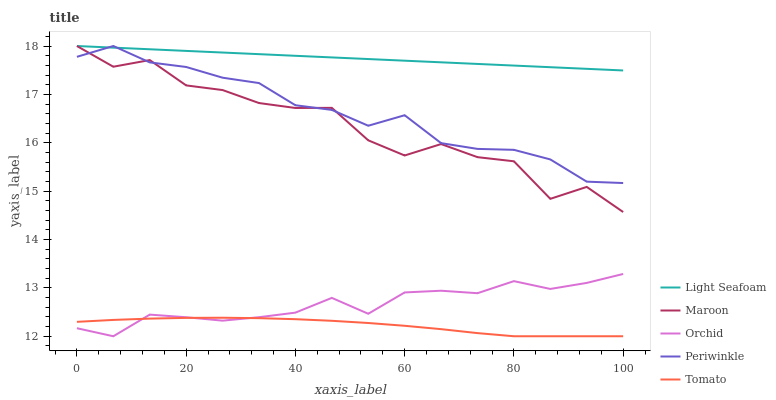Does Tomato have the minimum area under the curve?
Answer yes or no. Yes. Does Light Seafoam have the maximum area under the curve?
Answer yes or no. Yes. Does Periwinkle have the minimum area under the curve?
Answer yes or no. No. Does Periwinkle have the maximum area under the curve?
Answer yes or no. No. Is Light Seafoam the smoothest?
Answer yes or no. Yes. Is Maroon the roughest?
Answer yes or no. Yes. Is Periwinkle the smoothest?
Answer yes or no. No. Is Periwinkle the roughest?
Answer yes or no. No. Does Tomato have the lowest value?
Answer yes or no. Yes. Does Periwinkle have the lowest value?
Answer yes or no. No. Does Maroon have the highest value?
Answer yes or no. Yes. Does Orchid have the highest value?
Answer yes or no. No. Is Orchid less than Maroon?
Answer yes or no. Yes. Is Periwinkle greater than Orchid?
Answer yes or no. Yes. Does Periwinkle intersect Maroon?
Answer yes or no. Yes. Is Periwinkle less than Maroon?
Answer yes or no. No. Is Periwinkle greater than Maroon?
Answer yes or no. No. Does Orchid intersect Maroon?
Answer yes or no. No. 